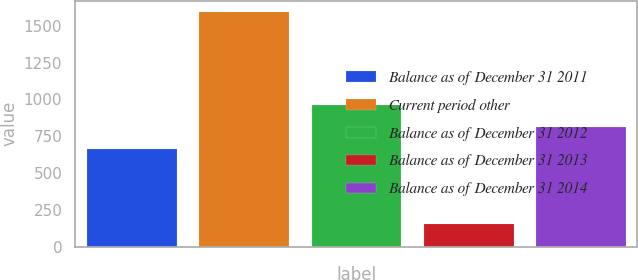<chart> <loc_0><loc_0><loc_500><loc_500><bar_chart><fcel>Balance as of December 31 2011<fcel>Current period other<fcel>Balance as of December 31 2012<fcel>Balance as of December 31 2013<fcel>Balance as of December 31 2014<nl><fcel>663<fcel>1591<fcel>959.4<fcel>157<fcel>816<nl></chart> 